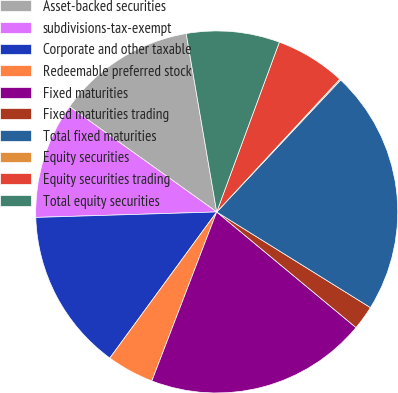Convert chart. <chart><loc_0><loc_0><loc_500><loc_500><pie_chart><fcel>Asset-backed securities<fcel>subdivisions-tax-exempt<fcel>Corporate and other taxable<fcel>Redeemable preferred stock<fcel>Fixed maturities<fcel>Fixed maturities trading<fcel>Total fixed maturities<fcel>Equity securities<fcel>Equity securities trading<fcel>Total equity securities<nl><fcel>12.42%<fcel>10.37%<fcel>14.47%<fcel>4.22%<fcel>19.81%<fcel>2.17%<fcel>21.86%<fcel>0.11%<fcel>6.27%<fcel>8.32%<nl></chart> 